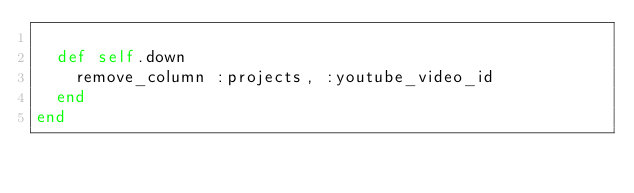<code> <loc_0><loc_0><loc_500><loc_500><_Ruby_>
  def self.down
    remove_column :projects, :youtube_video_id
  end
end
</code> 